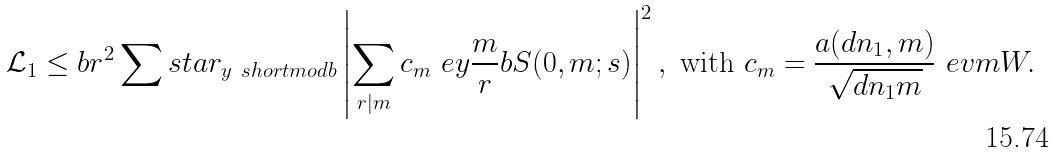<formula> <loc_0><loc_0><loc_500><loc_500>\mathcal { L } _ { 1 } \leq b r ^ { 2 } \sum s t a r _ { y \ s h o r t m o d { b } } \left | \sum _ { r | m } c _ { m } \ e { y \frac { m } { r } } { b } S ( 0 , m ; s ) \right | ^ { 2 } , \text { with } c _ { m } = \frac { a ( d n _ { 1 } , m ) } { \sqrt { d n _ { 1 } m } } \ e { v m } { W } .</formula> 